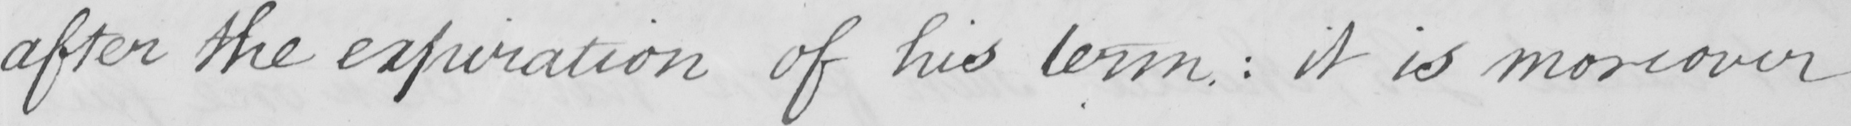What text is written in this handwritten line? after the expiration of his term  :  it is moreover 